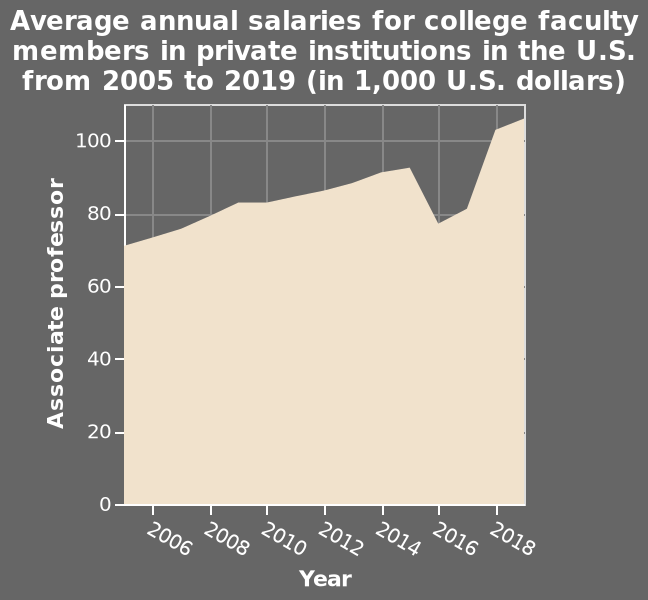<image>
please summary the statistics and relations of the chart The overall trend within the chart is upwards, there is a dip in 2016, however this peaks again in 2019 at over 100,000. The years 2005 to 2015 show a steady incline from over 70,000 to over 90,000. Did the values consistently increase from 2005 to 2015? Yes, the values consistently increased from over 70,000 to over 90,000 from 2005 to 2015. What does the x-axis represent?  The x-axis represents the year from 2006 to 2018 on a linear scale. 